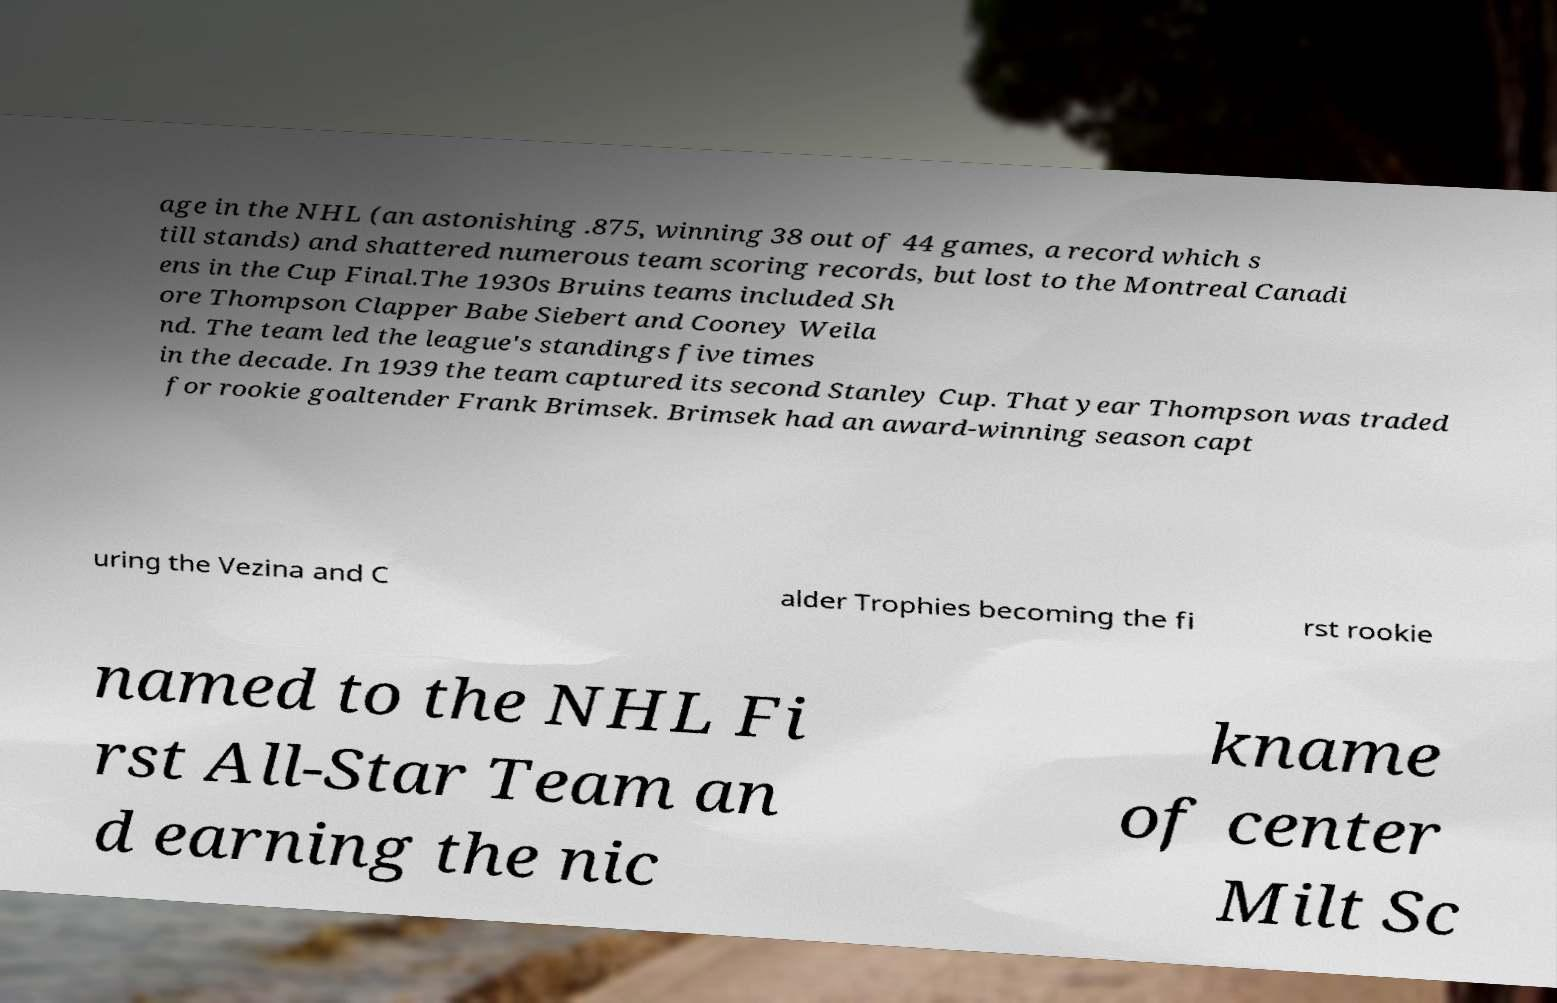Can you read and provide the text displayed in the image?This photo seems to have some interesting text. Can you extract and type it out for me? age in the NHL (an astonishing .875, winning 38 out of 44 games, a record which s till stands) and shattered numerous team scoring records, but lost to the Montreal Canadi ens in the Cup Final.The 1930s Bruins teams included Sh ore Thompson Clapper Babe Siebert and Cooney Weila nd. The team led the league's standings five times in the decade. In 1939 the team captured its second Stanley Cup. That year Thompson was traded for rookie goaltender Frank Brimsek. Brimsek had an award-winning season capt uring the Vezina and C alder Trophies becoming the fi rst rookie named to the NHL Fi rst All-Star Team an d earning the nic kname of center Milt Sc 